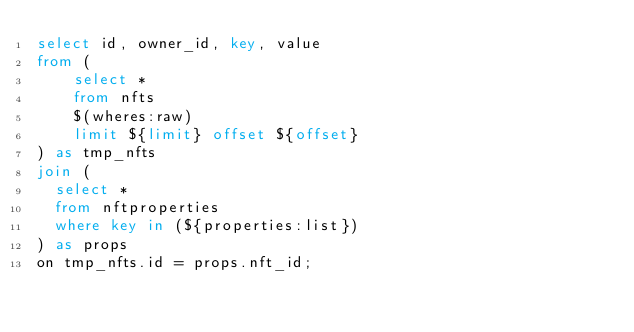<code> <loc_0><loc_0><loc_500><loc_500><_SQL_>select id, owner_id, key, value
from (
    select *
    from nfts
    $(wheres:raw)
    limit ${limit} offset ${offset}
) as tmp_nfts
join (
	select *
	from nftproperties
	where key in (${properties:list})
) as props
on tmp_nfts.id = props.nft_id;
</code> 